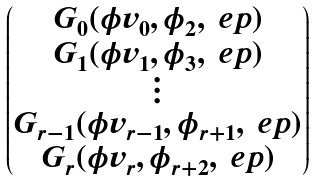Convert formula to latex. <formula><loc_0><loc_0><loc_500><loc_500>\begin{pmatrix} G _ { 0 } ( \phi v _ { 0 } , \phi _ { 2 } , \ e p ) \\ G _ { 1 } ( \phi v _ { 1 } , \phi _ { 3 } , \ e p ) \\ \vdots \\ G _ { r - 1 } ( \phi v _ { r - 1 } , \phi _ { r + 1 } , \ e p ) \\ G _ { r } ( \phi v _ { r } , \phi _ { r + 2 } , \ e p ) \end{pmatrix}</formula> 